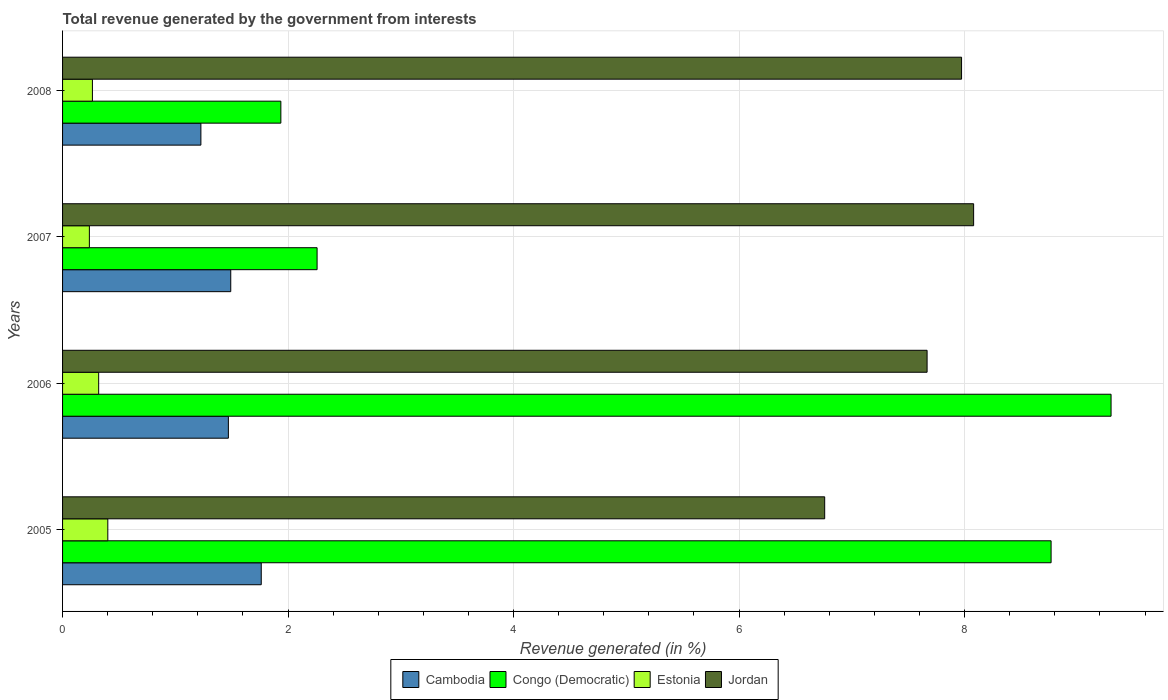How many different coloured bars are there?
Your response must be concise. 4. How many groups of bars are there?
Your answer should be compact. 4. Are the number of bars per tick equal to the number of legend labels?
Provide a succinct answer. Yes. How many bars are there on the 3rd tick from the bottom?
Keep it short and to the point. 4. What is the label of the 4th group of bars from the top?
Keep it short and to the point. 2005. In how many cases, is the number of bars for a given year not equal to the number of legend labels?
Your response must be concise. 0. What is the total revenue generated in Jordan in 2005?
Make the answer very short. 6.76. Across all years, what is the maximum total revenue generated in Cambodia?
Make the answer very short. 1.76. Across all years, what is the minimum total revenue generated in Jordan?
Your response must be concise. 6.76. What is the total total revenue generated in Congo (Democratic) in the graph?
Give a very brief answer. 22.26. What is the difference between the total revenue generated in Estonia in 2006 and that in 2008?
Give a very brief answer. 0.06. What is the difference between the total revenue generated in Cambodia in 2005 and the total revenue generated in Congo (Democratic) in 2008?
Provide a succinct answer. -0.17. What is the average total revenue generated in Congo (Democratic) per year?
Provide a succinct answer. 5.56. In the year 2006, what is the difference between the total revenue generated in Cambodia and total revenue generated in Jordan?
Provide a short and direct response. -6.2. In how many years, is the total revenue generated in Jordan greater than 8 %?
Make the answer very short. 1. What is the ratio of the total revenue generated in Congo (Democratic) in 2005 to that in 2006?
Make the answer very short. 0.94. Is the total revenue generated in Jordan in 2005 less than that in 2008?
Provide a succinct answer. Yes. What is the difference between the highest and the second highest total revenue generated in Jordan?
Your response must be concise. 0.11. What is the difference between the highest and the lowest total revenue generated in Estonia?
Your answer should be compact. 0.16. In how many years, is the total revenue generated in Congo (Democratic) greater than the average total revenue generated in Congo (Democratic) taken over all years?
Give a very brief answer. 2. Is the sum of the total revenue generated in Jordan in 2006 and 2008 greater than the maximum total revenue generated in Congo (Democratic) across all years?
Give a very brief answer. Yes. Is it the case that in every year, the sum of the total revenue generated in Jordan and total revenue generated in Cambodia is greater than the sum of total revenue generated in Congo (Democratic) and total revenue generated in Estonia?
Your answer should be compact. No. What does the 4th bar from the top in 2007 represents?
Offer a very short reply. Cambodia. What does the 1st bar from the bottom in 2007 represents?
Keep it short and to the point. Cambodia. Does the graph contain any zero values?
Provide a succinct answer. No. Does the graph contain grids?
Your answer should be very brief. Yes. How are the legend labels stacked?
Your answer should be compact. Horizontal. What is the title of the graph?
Keep it short and to the point. Total revenue generated by the government from interests. What is the label or title of the X-axis?
Provide a succinct answer. Revenue generated (in %). What is the label or title of the Y-axis?
Offer a very short reply. Years. What is the Revenue generated (in %) in Cambodia in 2005?
Give a very brief answer. 1.76. What is the Revenue generated (in %) of Congo (Democratic) in 2005?
Your answer should be compact. 8.77. What is the Revenue generated (in %) in Estonia in 2005?
Offer a very short reply. 0.4. What is the Revenue generated (in %) in Jordan in 2005?
Your answer should be very brief. 6.76. What is the Revenue generated (in %) of Cambodia in 2006?
Keep it short and to the point. 1.47. What is the Revenue generated (in %) in Congo (Democratic) in 2006?
Your response must be concise. 9.3. What is the Revenue generated (in %) in Estonia in 2006?
Your answer should be compact. 0.32. What is the Revenue generated (in %) in Jordan in 2006?
Provide a succinct answer. 7.67. What is the Revenue generated (in %) of Cambodia in 2007?
Provide a short and direct response. 1.49. What is the Revenue generated (in %) of Congo (Democratic) in 2007?
Give a very brief answer. 2.26. What is the Revenue generated (in %) of Estonia in 2007?
Your response must be concise. 0.24. What is the Revenue generated (in %) in Jordan in 2007?
Offer a terse response. 8.08. What is the Revenue generated (in %) in Cambodia in 2008?
Your answer should be very brief. 1.23. What is the Revenue generated (in %) of Congo (Democratic) in 2008?
Your answer should be very brief. 1.94. What is the Revenue generated (in %) of Estonia in 2008?
Provide a succinct answer. 0.26. What is the Revenue generated (in %) of Jordan in 2008?
Your answer should be compact. 7.97. Across all years, what is the maximum Revenue generated (in %) of Cambodia?
Your answer should be compact. 1.76. Across all years, what is the maximum Revenue generated (in %) of Congo (Democratic)?
Your answer should be very brief. 9.3. Across all years, what is the maximum Revenue generated (in %) in Estonia?
Make the answer very short. 0.4. Across all years, what is the maximum Revenue generated (in %) of Jordan?
Keep it short and to the point. 8.08. Across all years, what is the minimum Revenue generated (in %) of Cambodia?
Make the answer very short. 1.23. Across all years, what is the minimum Revenue generated (in %) in Congo (Democratic)?
Make the answer very short. 1.94. Across all years, what is the minimum Revenue generated (in %) in Estonia?
Offer a very short reply. 0.24. Across all years, what is the minimum Revenue generated (in %) of Jordan?
Your response must be concise. 6.76. What is the total Revenue generated (in %) of Cambodia in the graph?
Give a very brief answer. 5.95. What is the total Revenue generated (in %) of Congo (Democratic) in the graph?
Make the answer very short. 22.26. What is the total Revenue generated (in %) in Estonia in the graph?
Keep it short and to the point. 1.22. What is the total Revenue generated (in %) of Jordan in the graph?
Ensure brevity in your answer.  30.48. What is the difference between the Revenue generated (in %) in Cambodia in 2005 and that in 2006?
Your answer should be very brief. 0.29. What is the difference between the Revenue generated (in %) in Congo (Democratic) in 2005 and that in 2006?
Keep it short and to the point. -0.53. What is the difference between the Revenue generated (in %) of Estonia in 2005 and that in 2006?
Your answer should be compact. 0.08. What is the difference between the Revenue generated (in %) in Jordan in 2005 and that in 2006?
Offer a terse response. -0.91. What is the difference between the Revenue generated (in %) of Cambodia in 2005 and that in 2007?
Your answer should be very brief. 0.27. What is the difference between the Revenue generated (in %) in Congo (Democratic) in 2005 and that in 2007?
Your answer should be compact. 6.51. What is the difference between the Revenue generated (in %) in Estonia in 2005 and that in 2007?
Give a very brief answer. 0.16. What is the difference between the Revenue generated (in %) in Jordan in 2005 and that in 2007?
Ensure brevity in your answer.  -1.32. What is the difference between the Revenue generated (in %) of Cambodia in 2005 and that in 2008?
Provide a succinct answer. 0.54. What is the difference between the Revenue generated (in %) of Congo (Democratic) in 2005 and that in 2008?
Make the answer very short. 6.83. What is the difference between the Revenue generated (in %) in Estonia in 2005 and that in 2008?
Make the answer very short. 0.14. What is the difference between the Revenue generated (in %) in Jordan in 2005 and that in 2008?
Provide a short and direct response. -1.21. What is the difference between the Revenue generated (in %) of Cambodia in 2006 and that in 2007?
Provide a succinct answer. -0.02. What is the difference between the Revenue generated (in %) in Congo (Democratic) in 2006 and that in 2007?
Your answer should be compact. 7.04. What is the difference between the Revenue generated (in %) of Estonia in 2006 and that in 2007?
Make the answer very short. 0.08. What is the difference between the Revenue generated (in %) of Jordan in 2006 and that in 2007?
Provide a short and direct response. -0.41. What is the difference between the Revenue generated (in %) in Cambodia in 2006 and that in 2008?
Your answer should be very brief. 0.24. What is the difference between the Revenue generated (in %) in Congo (Democratic) in 2006 and that in 2008?
Provide a short and direct response. 7.36. What is the difference between the Revenue generated (in %) in Estonia in 2006 and that in 2008?
Provide a short and direct response. 0.06. What is the difference between the Revenue generated (in %) in Jordan in 2006 and that in 2008?
Your answer should be compact. -0.31. What is the difference between the Revenue generated (in %) of Cambodia in 2007 and that in 2008?
Your answer should be compact. 0.26. What is the difference between the Revenue generated (in %) in Congo (Democratic) in 2007 and that in 2008?
Ensure brevity in your answer.  0.32. What is the difference between the Revenue generated (in %) of Estonia in 2007 and that in 2008?
Your answer should be very brief. -0.03. What is the difference between the Revenue generated (in %) of Jordan in 2007 and that in 2008?
Provide a succinct answer. 0.11. What is the difference between the Revenue generated (in %) of Cambodia in 2005 and the Revenue generated (in %) of Congo (Democratic) in 2006?
Your answer should be very brief. -7.54. What is the difference between the Revenue generated (in %) in Cambodia in 2005 and the Revenue generated (in %) in Estonia in 2006?
Make the answer very short. 1.44. What is the difference between the Revenue generated (in %) of Cambodia in 2005 and the Revenue generated (in %) of Jordan in 2006?
Give a very brief answer. -5.91. What is the difference between the Revenue generated (in %) in Congo (Democratic) in 2005 and the Revenue generated (in %) in Estonia in 2006?
Provide a succinct answer. 8.45. What is the difference between the Revenue generated (in %) in Congo (Democratic) in 2005 and the Revenue generated (in %) in Jordan in 2006?
Offer a terse response. 1.1. What is the difference between the Revenue generated (in %) of Estonia in 2005 and the Revenue generated (in %) of Jordan in 2006?
Provide a short and direct response. -7.27. What is the difference between the Revenue generated (in %) of Cambodia in 2005 and the Revenue generated (in %) of Congo (Democratic) in 2007?
Your answer should be very brief. -0.5. What is the difference between the Revenue generated (in %) in Cambodia in 2005 and the Revenue generated (in %) in Estonia in 2007?
Make the answer very short. 1.52. What is the difference between the Revenue generated (in %) of Cambodia in 2005 and the Revenue generated (in %) of Jordan in 2007?
Ensure brevity in your answer.  -6.32. What is the difference between the Revenue generated (in %) of Congo (Democratic) in 2005 and the Revenue generated (in %) of Estonia in 2007?
Ensure brevity in your answer.  8.53. What is the difference between the Revenue generated (in %) in Congo (Democratic) in 2005 and the Revenue generated (in %) in Jordan in 2007?
Your response must be concise. 0.69. What is the difference between the Revenue generated (in %) of Estonia in 2005 and the Revenue generated (in %) of Jordan in 2007?
Your response must be concise. -7.68. What is the difference between the Revenue generated (in %) of Cambodia in 2005 and the Revenue generated (in %) of Congo (Democratic) in 2008?
Make the answer very short. -0.17. What is the difference between the Revenue generated (in %) in Cambodia in 2005 and the Revenue generated (in %) in Estonia in 2008?
Ensure brevity in your answer.  1.5. What is the difference between the Revenue generated (in %) of Cambodia in 2005 and the Revenue generated (in %) of Jordan in 2008?
Provide a succinct answer. -6.21. What is the difference between the Revenue generated (in %) in Congo (Democratic) in 2005 and the Revenue generated (in %) in Estonia in 2008?
Provide a succinct answer. 8.5. What is the difference between the Revenue generated (in %) of Congo (Democratic) in 2005 and the Revenue generated (in %) of Jordan in 2008?
Your response must be concise. 0.79. What is the difference between the Revenue generated (in %) in Estonia in 2005 and the Revenue generated (in %) in Jordan in 2008?
Your response must be concise. -7.57. What is the difference between the Revenue generated (in %) in Cambodia in 2006 and the Revenue generated (in %) in Congo (Democratic) in 2007?
Offer a very short reply. -0.79. What is the difference between the Revenue generated (in %) of Cambodia in 2006 and the Revenue generated (in %) of Estonia in 2007?
Make the answer very short. 1.23. What is the difference between the Revenue generated (in %) in Cambodia in 2006 and the Revenue generated (in %) in Jordan in 2007?
Your answer should be compact. -6.61. What is the difference between the Revenue generated (in %) in Congo (Democratic) in 2006 and the Revenue generated (in %) in Estonia in 2007?
Your response must be concise. 9.06. What is the difference between the Revenue generated (in %) in Congo (Democratic) in 2006 and the Revenue generated (in %) in Jordan in 2007?
Make the answer very short. 1.22. What is the difference between the Revenue generated (in %) in Estonia in 2006 and the Revenue generated (in %) in Jordan in 2007?
Ensure brevity in your answer.  -7.76. What is the difference between the Revenue generated (in %) of Cambodia in 2006 and the Revenue generated (in %) of Congo (Democratic) in 2008?
Your answer should be compact. -0.47. What is the difference between the Revenue generated (in %) in Cambodia in 2006 and the Revenue generated (in %) in Estonia in 2008?
Provide a short and direct response. 1.21. What is the difference between the Revenue generated (in %) in Cambodia in 2006 and the Revenue generated (in %) in Jordan in 2008?
Provide a short and direct response. -6.5. What is the difference between the Revenue generated (in %) of Congo (Democratic) in 2006 and the Revenue generated (in %) of Estonia in 2008?
Provide a short and direct response. 9.03. What is the difference between the Revenue generated (in %) of Congo (Democratic) in 2006 and the Revenue generated (in %) of Jordan in 2008?
Offer a very short reply. 1.33. What is the difference between the Revenue generated (in %) in Estonia in 2006 and the Revenue generated (in %) in Jordan in 2008?
Provide a succinct answer. -7.65. What is the difference between the Revenue generated (in %) in Cambodia in 2007 and the Revenue generated (in %) in Congo (Democratic) in 2008?
Your response must be concise. -0.44. What is the difference between the Revenue generated (in %) of Cambodia in 2007 and the Revenue generated (in %) of Estonia in 2008?
Provide a short and direct response. 1.23. What is the difference between the Revenue generated (in %) in Cambodia in 2007 and the Revenue generated (in %) in Jordan in 2008?
Offer a very short reply. -6.48. What is the difference between the Revenue generated (in %) of Congo (Democratic) in 2007 and the Revenue generated (in %) of Estonia in 2008?
Offer a terse response. 1.99. What is the difference between the Revenue generated (in %) of Congo (Democratic) in 2007 and the Revenue generated (in %) of Jordan in 2008?
Ensure brevity in your answer.  -5.72. What is the difference between the Revenue generated (in %) in Estonia in 2007 and the Revenue generated (in %) in Jordan in 2008?
Your response must be concise. -7.74. What is the average Revenue generated (in %) of Cambodia per year?
Your answer should be compact. 1.49. What is the average Revenue generated (in %) of Congo (Democratic) per year?
Ensure brevity in your answer.  5.56. What is the average Revenue generated (in %) of Estonia per year?
Your answer should be compact. 0.31. What is the average Revenue generated (in %) in Jordan per year?
Your answer should be very brief. 7.62. In the year 2005, what is the difference between the Revenue generated (in %) of Cambodia and Revenue generated (in %) of Congo (Democratic)?
Give a very brief answer. -7.01. In the year 2005, what is the difference between the Revenue generated (in %) in Cambodia and Revenue generated (in %) in Estonia?
Give a very brief answer. 1.36. In the year 2005, what is the difference between the Revenue generated (in %) of Cambodia and Revenue generated (in %) of Jordan?
Offer a very short reply. -5. In the year 2005, what is the difference between the Revenue generated (in %) in Congo (Democratic) and Revenue generated (in %) in Estonia?
Provide a short and direct response. 8.37. In the year 2005, what is the difference between the Revenue generated (in %) of Congo (Democratic) and Revenue generated (in %) of Jordan?
Ensure brevity in your answer.  2.01. In the year 2005, what is the difference between the Revenue generated (in %) of Estonia and Revenue generated (in %) of Jordan?
Offer a very short reply. -6.36. In the year 2006, what is the difference between the Revenue generated (in %) of Cambodia and Revenue generated (in %) of Congo (Democratic)?
Offer a very short reply. -7.83. In the year 2006, what is the difference between the Revenue generated (in %) of Cambodia and Revenue generated (in %) of Estonia?
Ensure brevity in your answer.  1.15. In the year 2006, what is the difference between the Revenue generated (in %) of Cambodia and Revenue generated (in %) of Jordan?
Your answer should be very brief. -6.2. In the year 2006, what is the difference between the Revenue generated (in %) in Congo (Democratic) and Revenue generated (in %) in Estonia?
Your answer should be very brief. 8.98. In the year 2006, what is the difference between the Revenue generated (in %) of Congo (Democratic) and Revenue generated (in %) of Jordan?
Your answer should be compact. 1.63. In the year 2006, what is the difference between the Revenue generated (in %) in Estonia and Revenue generated (in %) in Jordan?
Ensure brevity in your answer.  -7.35. In the year 2007, what is the difference between the Revenue generated (in %) of Cambodia and Revenue generated (in %) of Congo (Democratic)?
Provide a short and direct response. -0.77. In the year 2007, what is the difference between the Revenue generated (in %) in Cambodia and Revenue generated (in %) in Estonia?
Offer a very short reply. 1.25. In the year 2007, what is the difference between the Revenue generated (in %) in Cambodia and Revenue generated (in %) in Jordan?
Your answer should be very brief. -6.59. In the year 2007, what is the difference between the Revenue generated (in %) in Congo (Democratic) and Revenue generated (in %) in Estonia?
Offer a very short reply. 2.02. In the year 2007, what is the difference between the Revenue generated (in %) in Congo (Democratic) and Revenue generated (in %) in Jordan?
Your answer should be very brief. -5.82. In the year 2007, what is the difference between the Revenue generated (in %) of Estonia and Revenue generated (in %) of Jordan?
Your answer should be very brief. -7.84. In the year 2008, what is the difference between the Revenue generated (in %) of Cambodia and Revenue generated (in %) of Congo (Democratic)?
Give a very brief answer. -0.71. In the year 2008, what is the difference between the Revenue generated (in %) of Cambodia and Revenue generated (in %) of Estonia?
Keep it short and to the point. 0.96. In the year 2008, what is the difference between the Revenue generated (in %) in Cambodia and Revenue generated (in %) in Jordan?
Ensure brevity in your answer.  -6.75. In the year 2008, what is the difference between the Revenue generated (in %) in Congo (Democratic) and Revenue generated (in %) in Estonia?
Offer a terse response. 1.67. In the year 2008, what is the difference between the Revenue generated (in %) of Congo (Democratic) and Revenue generated (in %) of Jordan?
Your response must be concise. -6.04. In the year 2008, what is the difference between the Revenue generated (in %) in Estonia and Revenue generated (in %) in Jordan?
Offer a terse response. -7.71. What is the ratio of the Revenue generated (in %) in Cambodia in 2005 to that in 2006?
Offer a very short reply. 1.2. What is the ratio of the Revenue generated (in %) in Congo (Democratic) in 2005 to that in 2006?
Provide a succinct answer. 0.94. What is the ratio of the Revenue generated (in %) of Estonia in 2005 to that in 2006?
Make the answer very short. 1.25. What is the ratio of the Revenue generated (in %) of Jordan in 2005 to that in 2006?
Provide a succinct answer. 0.88. What is the ratio of the Revenue generated (in %) of Cambodia in 2005 to that in 2007?
Your answer should be compact. 1.18. What is the ratio of the Revenue generated (in %) of Congo (Democratic) in 2005 to that in 2007?
Make the answer very short. 3.88. What is the ratio of the Revenue generated (in %) in Estonia in 2005 to that in 2007?
Offer a very short reply. 1.69. What is the ratio of the Revenue generated (in %) of Jordan in 2005 to that in 2007?
Provide a succinct answer. 0.84. What is the ratio of the Revenue generated (in %) of Cambodia in 2005 to that in 2008?
Make the answer very short. 1.44. What is the ratio of the Revenue generated (in %) of Congo (Democratic) in 2005 to that in 2008?
Your answer should be very brief. 4.53. What is the ratio of the Revenue generated (in %) in Estonia in 2005 to that in 2008?
Offer a terse response. 1.52. What is the ratio of the Revenue generated (in %) of Jordan in 2005 to that in 2008?
Your response must be concise. 0.85. What is the ratio of the Revenue generated (in %) in Cambodia in 2006 to that in 2007?
Make the answer very short. 0.99. What is the ratio of the Revenue generated (in %) in Congo (Democratic) in 2006 to that in 2007?
Make the answer very short. 4.12. What is the ratio of the Revenue generated (in %) in Estonia in 2006 to that in 2007?
Your answer should be very brief. 1.35. What is the ratio of the Revenue generated (in %) in Jordan in 2006 to that in 2007?
Your answer should be very brief. 0.95. What is the ratio of the Revenue generated (in %) in Cambodia in 2006 to that in 2008?
Provide a succinct answer. 1.2. What is the ratio of the Revenue generated (in %) in Congo (Democratic) in 2006 to that in 2008?
Give a very brief answer. 4.8. What is the ratio of the Revenue generated (in %) of Estonia in 2006 to that in 2008?
Keep it short and to the point. 1.21. What is the ratio of the Revenue generated (in %) in Jordan in 2006 to that in 2008?
Give a very brief answer. 0.96. What is the ratio of the Revenue generated (in %) in Cambodia in 2007 to that in 2008?
Ensure brevity in your answer.  1.22. What is the ratio of the Revenue generated (in %) of Congo (Democratic) in 2007 to that in 2008?
Your answer should be compact. 1.17. What is the ratio of the Revenue generated (in %) of Estonia in 2007 to that in 2008?
Keep it short and to the point. 0.9. What is the ratio of the Revenue generated (in %) of Jordan in 2007 to that in 2008?
Ensure brevity in your answer.  1.01. What is the difference between the highest and the second highest Revenue generated (in %) of Cambodia?
Your response must be concise. 0.27. What is the difference between the highest and the second highest Revenue generated (in %) in Congo (Democratic)?
Provide a succinct answer. 0.53. What is the difference between the highest and the second highest Revenue generated (in %) in Estonia?
Your response must be concise. 0.08. What is the difference between the highest and the second highest Revenue generated (in %) of Jordan?
Your answer should be very brief. 0.11. What is the difference between the highest and the lowest Revenue generated (in %) of Cambodia?
Keep it short and to the point. 0.54. What is the difference between the highest and the lowest Revenue generated (in %) in Congo (Democratic)?
Ensure brevity in your answer.  7.36. What is the difference between the highest and the lowest Revenue generated (in %) of Estonia?
Make the answer very short. 0.16. What is the difference between the highest and the lowest Revenue generated (in %) of Jordan?
Make the answer very short. 1.32. 